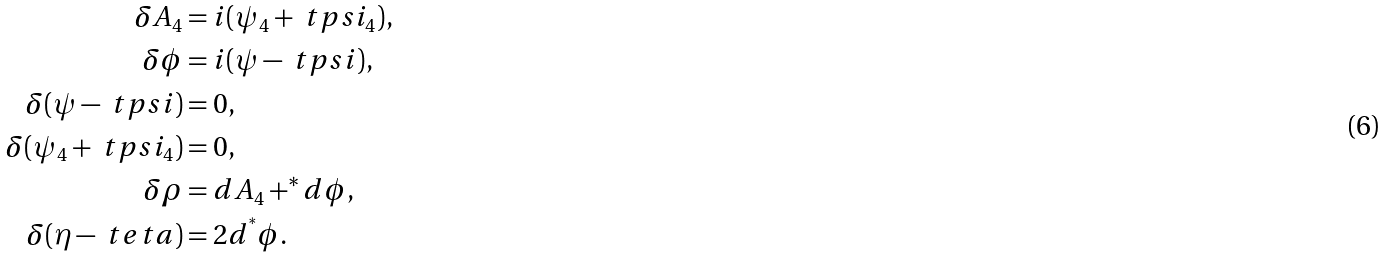<formula> <loc_0><loc_0><loc_500><loc_500>\delta A _ { 4 } & = i ( \psi _ { 4 } + \ t p s i _ { 4 } ) , \\ \delta \phi & = i ( \psi - \ t p s i ) , \\ \delta ( \psi - \ t p s i ) & = 0 , \\ \delta ( \psi _ { 4 } + \ t p s i _ { 4 } ) & = 0 , \\ \delta \rho & = d A _ { 4 } + ^ { * } d \phi , \\ \delta ( \eta - \ t e t a ) & = 2 d ^ { ^ { * } } \phi .</formula> 